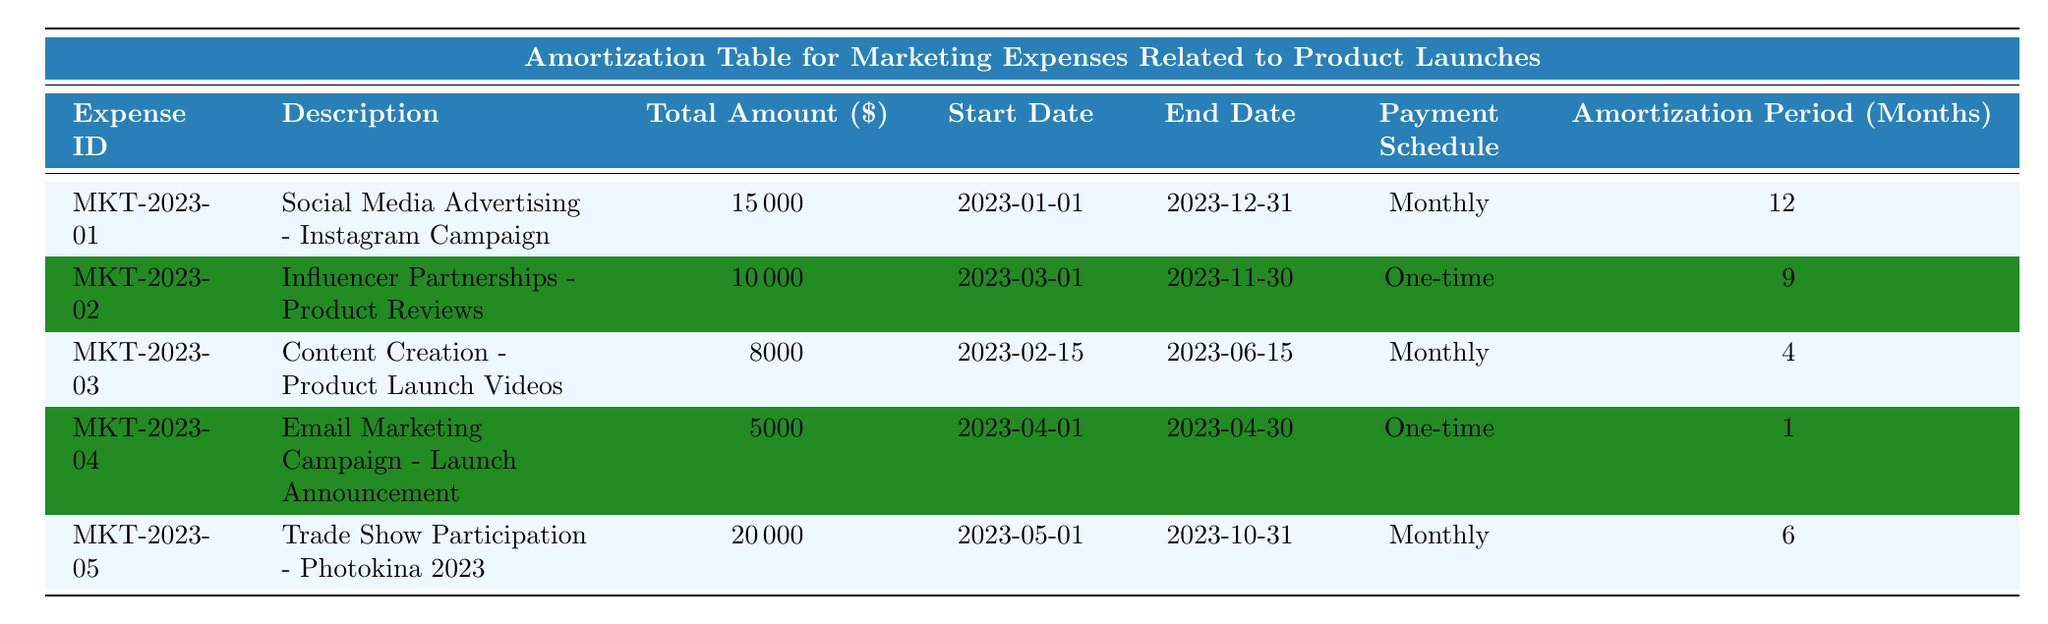What is the total amount allocated to "Social Media Advertising - Instagram Campaign"? The total amount for the expense with the description "Social Media Advertising - Instagram Campaign" is listed in the table. The row corresponding to this expense shows a total amount of $15,000.
Answer: 15000 What is the payment schedule for "Influencer Partnerships - Product Reviews"? The payment schedule for the expense described as "Influencer Partnerships - Product Reviews" is indicated in its respective row, which states it is a one-time payment.
Answer: One-time How many months is the amortization period for "Content Creation - Product Launch Videos"? The amortization period for the expense titled "Content Creation - Product Launch Videos" can be found in the table under the corresponding column, and it indicates an amortization period of 4 months.
Answer: 4 Which marketing expense has the highest total amount? To determine which marketing expense has the highest total amount, compare the total amounts across all expenses. The "Trade Show Participation - Photokina 2023" has the highest total amount of $20,000.
Answer: Trade Show Participation - Photokina 2023 Is the payment schedule for "Email Marketing Campaign - Launch Announcement" a monthly schedule? The payment schedule for the "Email Marketing Campaign - Launch Announcement" is a one-time payment according to the table, thus the answer to this question is no.
Answer: No What is the average amortization period for all expenses listed? To find the average amortization period, sum the amortization periods of all expenses: 12 + 9 + 4 + 1 + 6 = 32 months. There are 5 expenses in total, so dividing 32 by 5 gives an average amortization period of 6.4 months.
Answer: 6.4 What is the total amount for all marketing expenses? The total amount for all marketing expenses is calculated by adding together the total amounts of each expense: 15000 + 10000 + 8000 + 5000 + 20000 = 58000. Thus, the total amount is $58,000.
Answer: 58000 How many expenses have a one-time payment schedule? By inspecting the payment schedule column in the table, there are two expenses (Influencer Partnerships and Email Marketing Campaign) that are marked as one-time payments. Therefore, the count is 2.
Answer: 2 What is the total amortization period for expenses with a monthly payment schedule? The expenses with a monthly payment schedule are "Social Media Advertising" (12 months), "Content Creation" (4 months), and "Trade Show Participation" (6 months). Summing them gives 12 + 4 + 6 = 22 months total for these expenses.
Answer: 22 